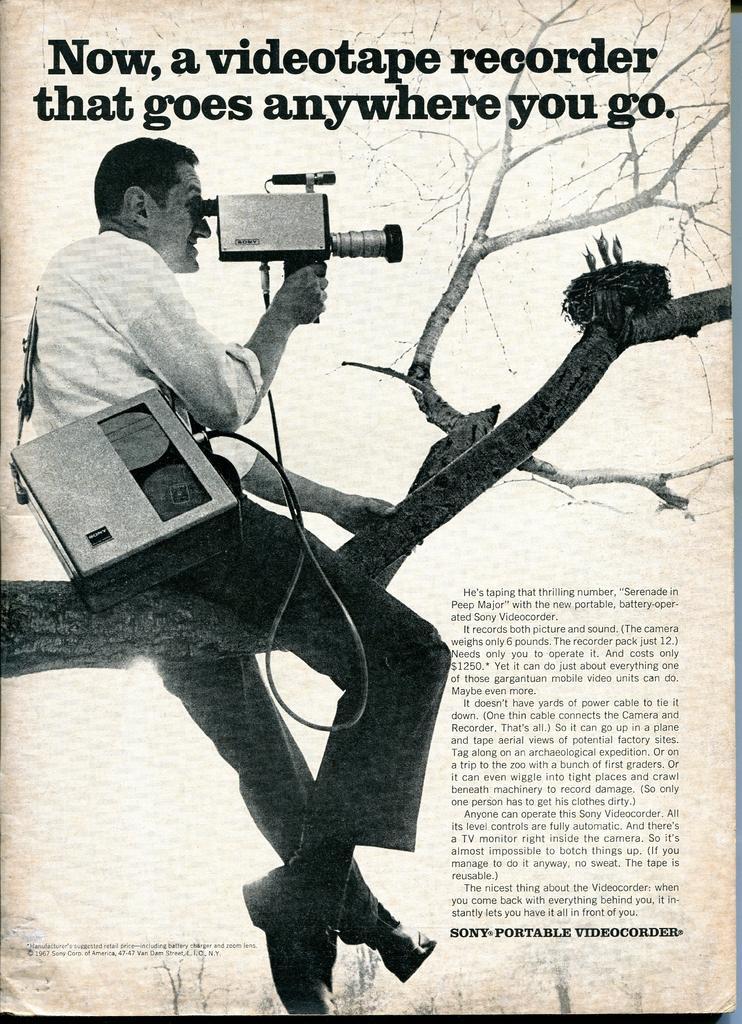Could you give a brief overview of what you see in this image? In this picture this is a paper and on the paper we can see a man is sitting on a branch and holding a camera and on the branch there is a nest and birds and on the paper it is written something. 